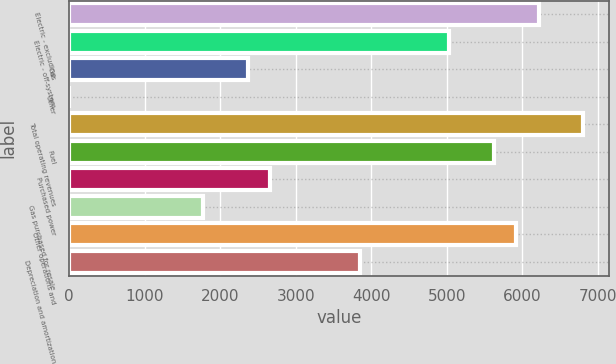Convert chart. <chart><loc_0><loc_0><loc_500><loc_500><bar_chart><fcel>Electric - excluding<fcel>Electric - off-system<fcel>Gas<fcel>Other<fcel>Total operating revenues<fcel>Fuel<fcel>Purchased power<fcel>Gas purchased for resale<fcel>Other operations and<fcel>Depreciation and amortization<nl><fcel>6217<fcel>5033<fcel>2369<fcel>1<fcel>6809<fcel>5625<fcel>2665<fcel>1777<fcel>5921<fcel>3849<nl></chart> 